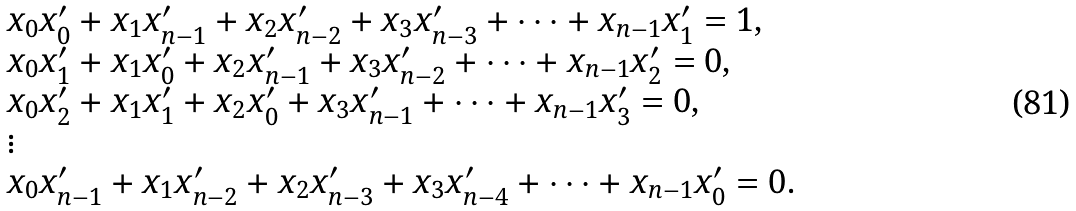Convert formula to latex. <formula><loc_0><loc_0><loc_500><loc_500>\begin{array} { l } x _ { 0 } x _ { 0 } ^ { \prime } + x _ { 1 } x _ { n - 1 } ^ { \prime } + x _ { 2 } x _ { n - 2 } ^ { \prime } + x _ { 3 } x _ { n - 3 } ^ { \prime } + \cdots + x _ { n - 1 } x _ { 1 } ^ { \prime } = 1 , \\ x _ { 0 } x _ { 1 } ^ { \prime } + x _ { 1 } x _ { 0 } ^ { \prime } + x _ { 2 } x _ { n - 1 } ^ { \prime } + x _ { 3 } x _ { n - 2 } ^ { \prime } + \cdots + x _ { n - 1 } x _ { 2 } ^ { \prime } = 0 , \\ x _ { 0 } x _ { 2 } ^ { \prime } + x _ { 1 } x _ { 1 } ^ { \prime } + x _ { 2 } x _ { 0 } ^ { \prime } + x _ { 3 } x _ { n - 1 } ^ { \prime } + \cdots + x _ { n - 1 } x _ { 3 } ^ { \prime } = 0 , \\ \vdots \\ x _ { 0 } x _ { n - 1 } ^ { \prime } + x _ { 1 } x _ { n - 2 } ^ { \prime } + x _ { 2 } x _ { n - 3 } ^ { \prime } + x _ { 3 } x _ { n - 4 } ^ { \prime } + \cdots + x _ { n - 1 } x _ { 0 } ^ { \prime } = 0 . \end{array}</formula> 